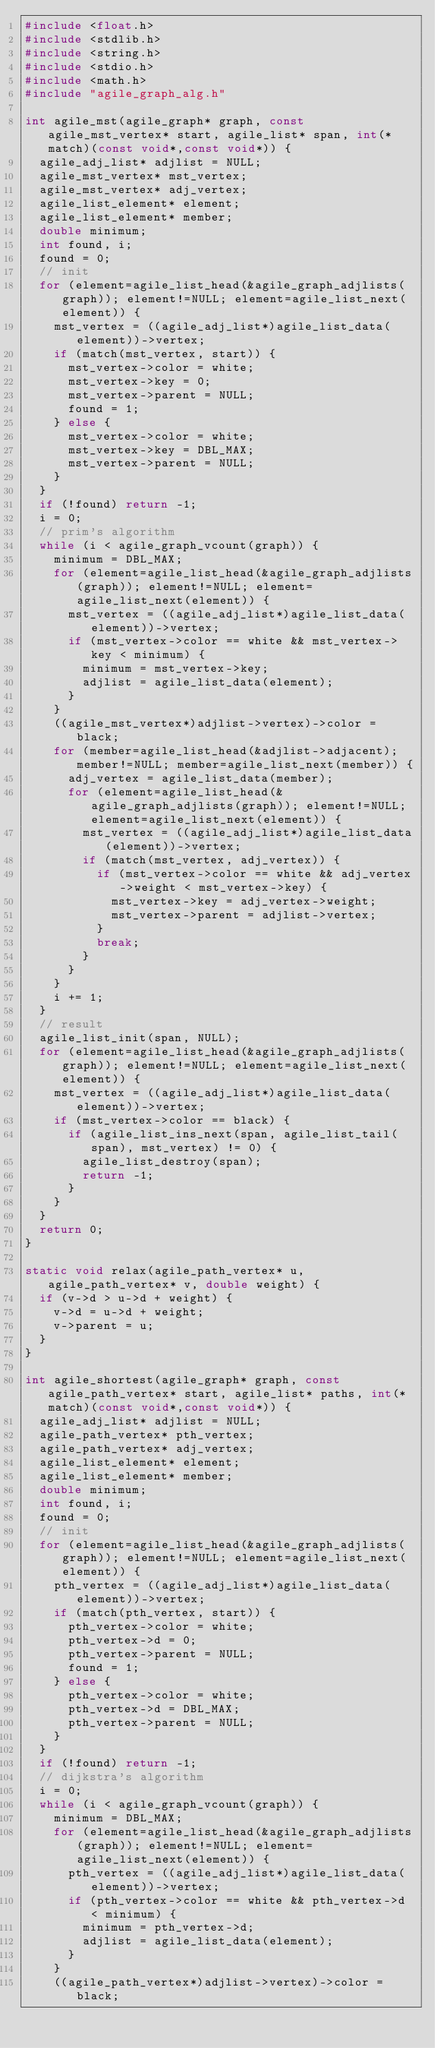<code> <loc_0><loc_0><loc_500><loc_500><_C_>#include <float.h>
#include <stdlib.h>
#include <string.h>
#include <stdio.h>
#include <math.h>
#include "agile_graph_alg.h"

int agile_mst(agile_graph* graph, const agile_mst_vertex* start, agile_list* span, int(*match)(const void*,const void*)) {
	agile_adj_list* adjlist = NULL;
	agile_mst_vertex* mst_vertex;
	agile_mst_vertex* adj_vertex;
	agile_list_element* element;
	agile_list_element* member;
	double minimum;
	int found, i;
	found = 0;
	// init
	for (element=agile_list_head(&agile_graph_adjlists(graph)); element!=NULL; element=agile_list_next(element)) {
		mst_vertex = ((agile_adj_list*)agile_list_data(element))->vertex;
		if (match(mst_vertex, start)) {
			mst_vertex->color = white;
			mst_vertex->key = 0;
			mst_vertex->parent = NULL;
			found = 1;
		} else {
			mst_vertex->color = white;
			mst_vertex->key = DBL_MAX;
			mst_vertex->parent = NULL;
		}
	}
	if (!found) return -1;
	i = 0;
	// prim's algorithm
	while (i < agile_graph_vcount(graph)) {
		minimum = DBL_MAX;
		for (element=agile_list_head(&agile_graph_adjlists(graph)); element!=NULL; element=agile_list_next(element)) {
			mst_vertex = ((agile_adj_list*)agile_list_data(element))->vertex;
			if (mst_vertex->color == white && mst_vertex->key < minimum) {
				minimum = mst_vertex->key;
				adjlist = agile_list_data(element);
			}
		}
		((agile_mst_vertex*)adjlist->vertex)->color = black;
		for (member=agile_list_head(&adjlist->adjacent); member!=NULL; member=agile_list_next(member)) {
			adj_vertex = agile_list_data(member);
			for (element=agile_list_head(&agile_graph_adjlists(graph)); element!=NULL; element=agile_list_next(element)) {
				mst_vertex = ((agile_adj_list*)agile_list_data(element))->vertex;
				if (match(mst_vertex, adj_vertex)) {
					if (mst_vertex->color == white && adj_vertex->weight < mst_vertex->key) {
						mst_vertex->key = adj_vertex->weight;
						mst_vertex->parent = adjlist->vertex;
					}
					break;
				}
			}
		}
		i += 1;
	}
	// result
	agile_list_init(span, NULL);
	for (element=agile_list_head(&agile_graph_adjlists(graph)); element!=NULL; element=agile_list_next(element)) {
		mst_vertex = ((agile_adj_list*)agile_list_data(element))->vertex;
		if (mst_vertex->color == black) {
			if (agile_list_ins_next(span, agile_list_tail(span), mst_vertex) != 0) {
				agile_list_destroy(span);
				return -1;
			}
		}
	}
	return 0;
}

static void relax(agile_path_vertex* u, agile_path_vertex* v, double weight) {
	if (v->d > u->d + weight) {
		v->d = u->d + weight;
		v->parent = u;
	}
}

int agile_shortest(agile_graph* graph, const agile_path_vertex* start, agile_list* paths, int(*match)(const void*,const void*)) {
	agile_adj_list* adjlist = NULL;
	agile_path_vertex* pth_vertex;
	agile_path_vertex* adj_vertex;
	agile_list_element* element;
	agile_list_element* member;
	double minimum;
	int found, i;
	found = 0;
	// init
	for (element=agile_list_head(&agile_graph_adjlists(graph)); element!=NULL; element=agile_list_next(element)) {
		pth_vertex = ((agile_adj_list*)agile_list_data(element))->vertex;
		if (match(pth_vertex, start)) {
			pth_vertex->color = white;
			pth_vertex->d = 0;
			pth_vertex->parent = NULL;
			found = 1;
		} else {
			pth_vertex->color = white;
			pth_vertex->d = DBL_MAX;
			pth_vertex->parent = NULL;
		}
	}
	if (!found) return -1;
	// dijkstra's algorithm
	i = 0;
	while (i < agile_graph_vcount(graph)) {
		minimum = DBL_MAX;
		for (element=agile_list_head(&agile_graph_adjlists(graph)); element!=NULL; element=agile_list_next(element)) {
			pth_vertex = ((agile_adj_list*)agile_list_data(element))->vertex;
			if (pth_vertex->color == white && pth_vertex->d < minimum) {
				minimum = pth_vertex->d;
				adjlist = agile_list_data(element);
			}
		}
		((agile_path_vertex*)adjlist->vertex)->color = black;</code> 